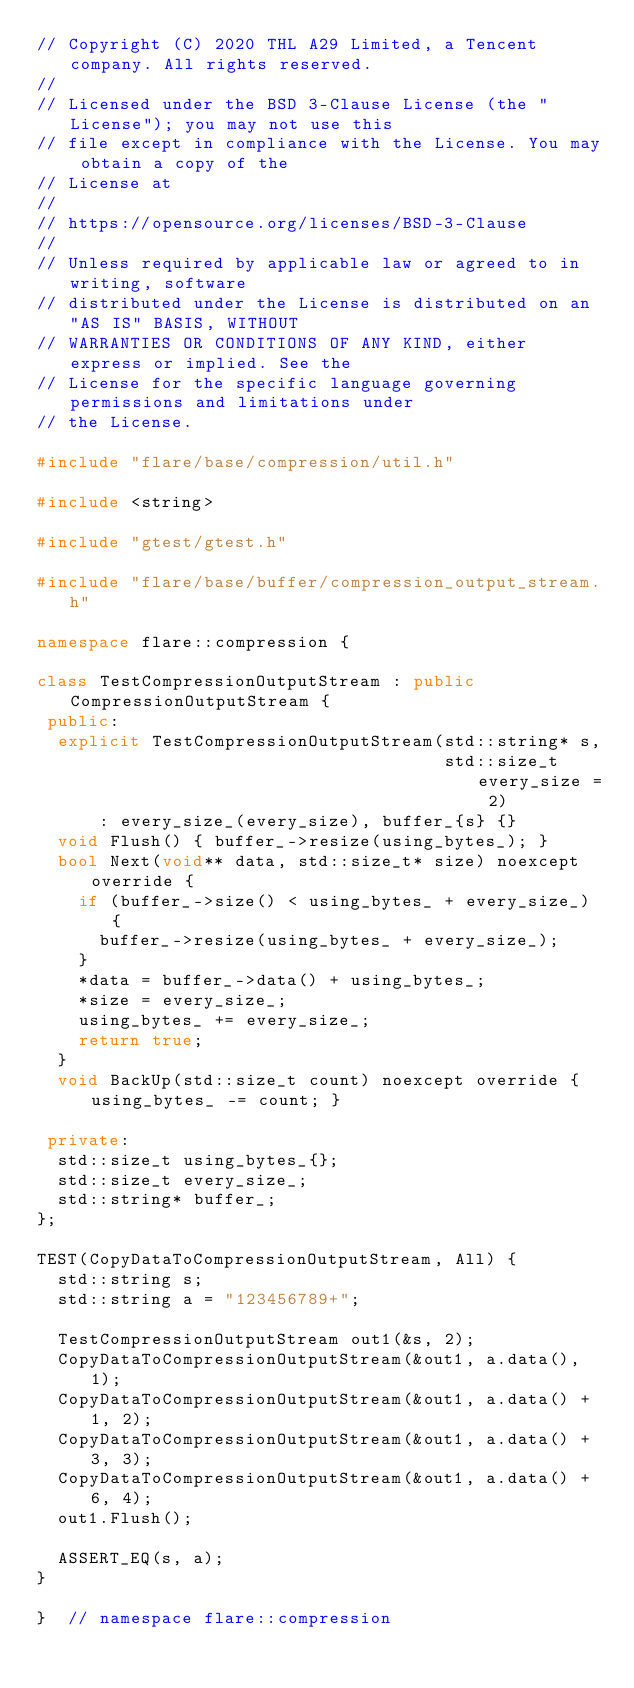Convert code to text. <code><loc_0><loc_0><loc_500><loc_500><_C++_>// Copyright (C) 2020 THL A29 Limited, a Tencent company. All rights reserved.
//
// Licensed under the BSD 3-Clause License (the "License"); you may not use this
// file except in compliance with the License. You may obtain a copy of the
// License at
//
// https://opensource.org/licenses/BSD-3-Clause
//
// Unless required by applicable law or agreed to in writing, software
// distributed under the License is distributed on an "AS IS" BASIS, WITHOUT
// WARRANTIES OR CONDITIONS OF ANY KIND, either express or implied. See the
// License for the specific language governing permissions and limitations under
// the License.

#include "flare/base/compression/util.h"

#include <string>

#include "gtest/gtest.h"

#include "flare/base/buffer/compression_output_stream.h"

namespace flare::compression {

class TestCompressionOutputStream : public CompressionOutputStream {
 public:
  explicit TestCompressionOutputStream(std::string* s,
                                       std::size_t every_size = 2)
      : every_size_(every_size), buffer_{s} {}
  void Flush() { buffer_->resize(using_bytes_); }
  bool Next(void** data, std::size_t* size) noexcept override {
    if (buffer_->size() < using_bytes_ + every_size_) {
      buffer_->resize(using_bytes_ + every_size_);
    }
    *data = buffer_->data() + using_bytes_;
    *size = every_size_;
    using_bytes_ += every_size_;
    return true;
  }
  void BackUp(std::size_t count) noexcept override { using_bytes_ -= count; }

 private:
  std::size_t using_bytes_{};
  std::size_t every_size_;
  std::string* buffer_;
};

TEST(CopyDataToCompressionOutputStream, All) {
  std::string s;
  std::string a = "123456789+";

  TestCompressionOutputStream out1(&s, 2);
  CopyDataToCompressionOutputStream(&out1, a.data(), 1);
  CopyDataToCompressionOutputStream(&out1, a.data() + 1, 2);
  CopyDataToCompressionOutputStream(&out1, a.data() + 3, 3);
  CopyDataToCompressionOutputStream(&out1, a.data() + 6, 4);
  out1.Flush();

  ASSERT_EQ(s, a);
}

}  // namespace flare::compression
</code> 